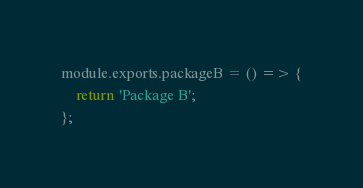Convert code to text. <code><loc_0><loc_0><loc_500><loc_500><_JavaScript_>module.exports.packageB = () => {
    return 'Package B';
};
</code> 